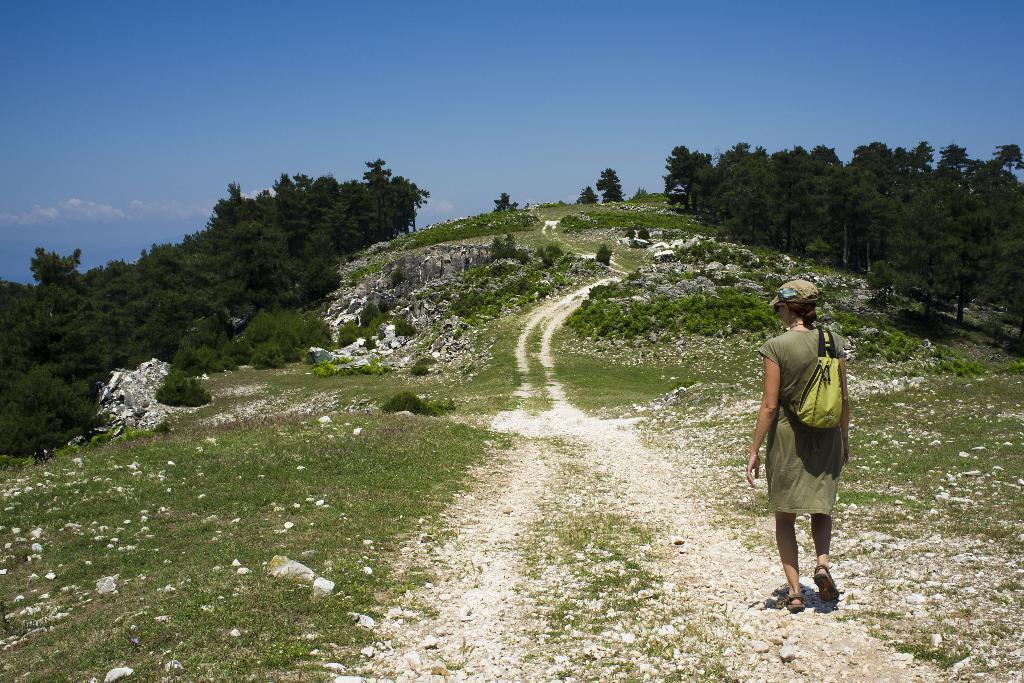Please provide a concise description of this image. In this image there is a person walking, in front of the person there is grass, bushes, rocks and trees, at the top of the image there are clouds in the sky. 